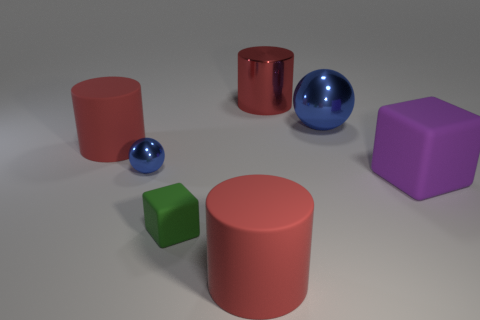Add 3 rubber blocks. How many objects exist? 10 Subtract all balls. How many objects are left? 5 Add 7 matte cubes. How many matte cubes are left? 9 Add 4 blue spheres. How many blue spheres exist? 6 Subtract 0 cyan cylinders. How many objects are left? 7 Subtract all big balls. Subtract all large matte cylinders. How many objects are left? 4 